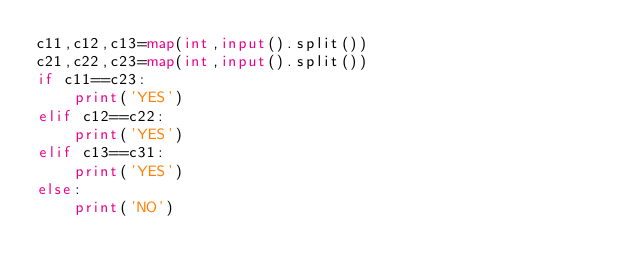<code> <loc_0><loc_0><loc_500><loc_500><_Python_>c11,c12,c13=map(int,input().split())
c21,c22,c23=map(int,input().split())
if c11==c23:
    print('YES')
elif c12==c22:
    print('YES')
elif c13==c31:
    print('YES')
else:
    print('NO')</code> 